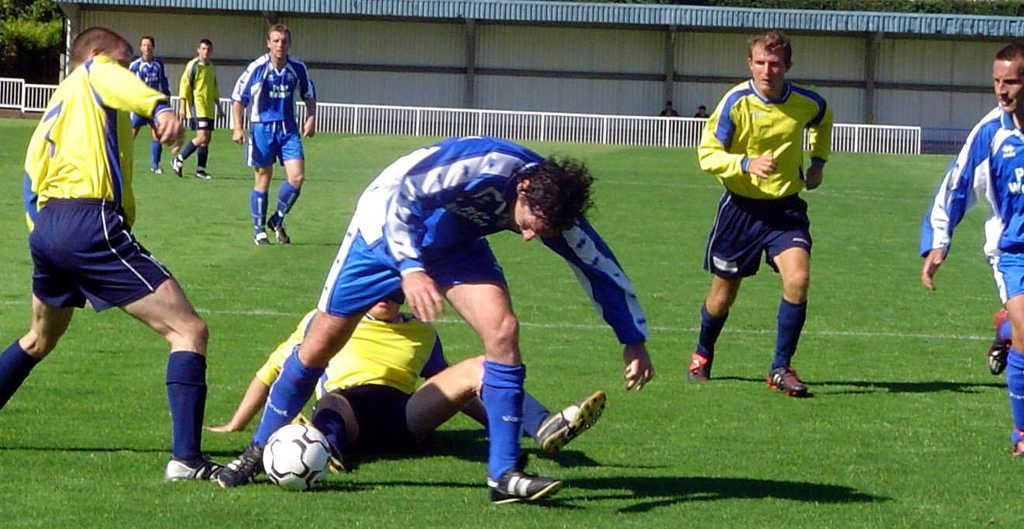What is the primary activity of the men in the image? The men are on the grass, and one of them is sitting. What object is present in the image that might be related to the men's activity? There is a football in the image. Can you describe the setting where the men are located? The men are on the grass, and there is a fence in the background. How many additional people can be seen in the background? There are two more persons in the background. What type of wish can be granted by the crowd in the image? There is no crowd present in the image, only a few men and two additional persons in the background. 